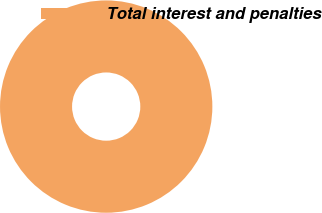Convert chart to OTSL. <chart><loc_0><loc_0><loc_500><loc_500><pie_chart><fcel>Total interest and penalties<nl><fcel>100.0%<nl></chart> 